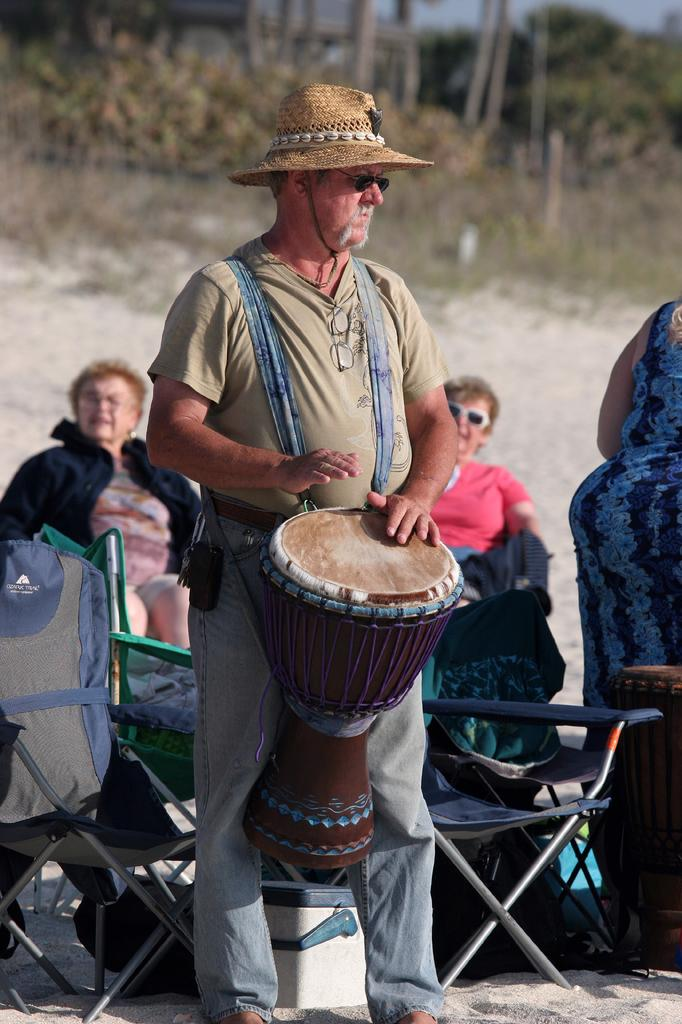What is the man in the image wearing on his head? The man is wearing a cap in the image. What is the man wearing that covers his eyes? The man is wearing goggles in the image. What is the man doing in the image? The man is playing a drum in the image. How many women are in the image? There are two women in the image. What are the women doing in the image? The women are sitting on chairs in the image. What is on one of the chairs? There is a bag on one of the chairs in the image. What can be seen in the background of the image? Trees and sand are visible in the background of the image. What type of mailbox can be seen in the image? There is no mailbox present in the image. What is the boundary between the sand and the trees in the image? The image does not show a boundary between the sand and the trees; it only shows the presence of both elements in the background. 